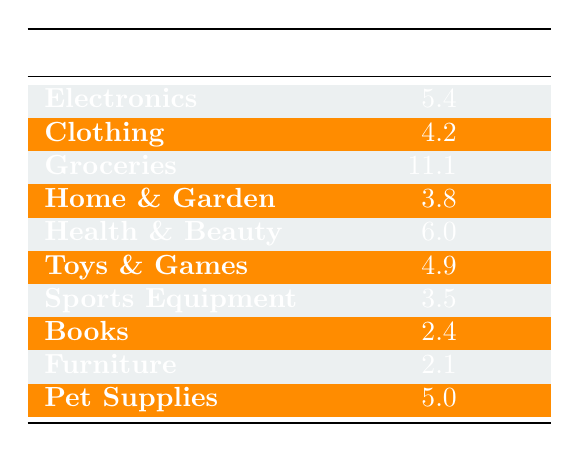What is the turnover rate for the Groceries category? The turnover rate for the Groceries category is directly listed in the table under the respective row. It shows a turnover rate of 11.1.
Answer: 11.1 Which product category has the highest turnover rate? By examining the turnover rates in the table, Groceries has the highest value at 11.1, which is greater than all other categories listed.
Answer: Groceries What is the average turnover rate of Electronics and Health & Beauty? The turnover rate for Electronics is 5.4 and for Health & Beauty is 6.0. To find the average, we sum these rates (5.4 + 6.0 = 11.4) and divide by 2, resulting in 11.4 / 2 = 5.7.
Answer: 5.7 Is the turnover rate for Clothing greater than that of Home & Garden? Clothing has a turnover rate of 4.2 and Home & Garden has a turnover rate of 3.8. Since 4.2 is greater than 3.8, the statement is true.
Answer: Yes What is the difference in turnover rates between Sports Equipment and Pet Supplies? Sports Equipment has a turnover rate of 3.5 and Pet Supplies has a turnover rate of 5.0. The difference is calculated by subtracting the lower rate from the higher rate (5.0 - 3.5 = 1.5).
Answer: 1.5 How many categories have turnover rates below 4? Reviewing the table, the categories with turnover rates below 4 are Home & Garden (3.8), Sports Equipment (3.5), Books (2.4), and Furniture (2.1). Counting these, there are four categories.
Answer: 4 Are there any product categories with a turnover rate of 2.5 or less? Upon checking the table, Books and Furniture are the two categories with turnover rates at 2.4 and 2.1 respectively, which are both below 2.5. Thus, the statement is true.
Answer: Yes Which product categories have a turnover rate greater than 5? From the table, the categories with rates greater than 5 are Electronics (5.4), Health & Beauty (6.0), and Groceries (11.1). This gives us three categories in total.
Answer: 3 What is the combined turnover rate of Toys & Games and Pet Supplies? The turnover rate for Toys & Games is 4.9 and for Pet Supplies it is 5.0. To find the combined rate, we add these together (4.9 + 5.0 = 9.9).
Answer: 9.9 